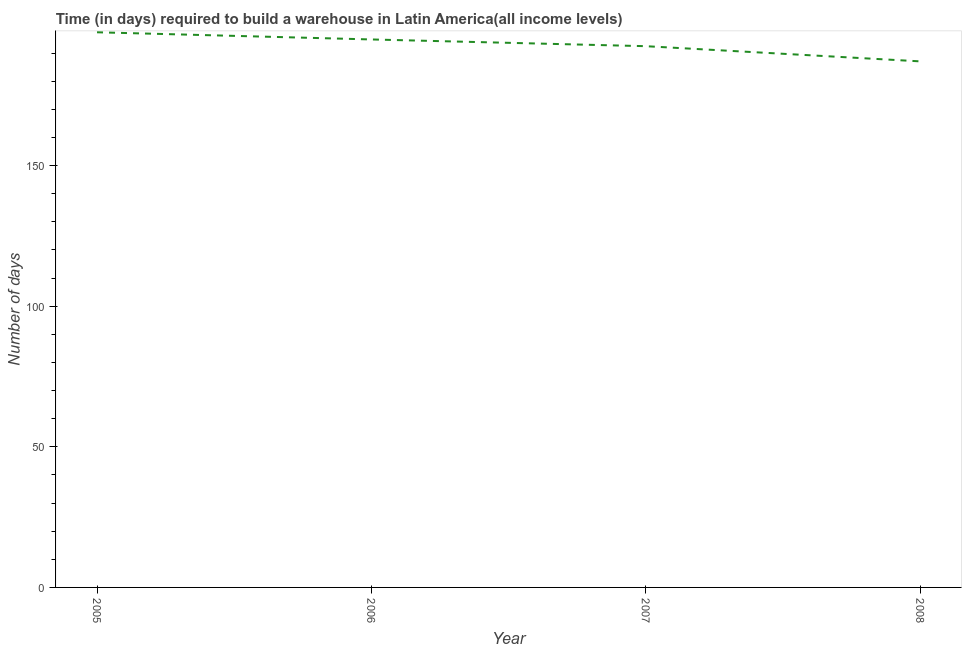What is the time required to build a warehouse in 2008?
Your answer should be compact. 187.07. Across all years, what is the maximum time required to build a warehouse?
Offer a very short reply. 197.41. Across all years, what is the minimum time required to build a warehouse?
Keep it short and to the point. 187.07. In which year was the time required to build a warehouse maximum?
Your answer should be compact. 2005. What is the sum of the time required to build a warehouse?
Ensure brevity in your answer.  771.81. What is the difference between the time required to build a warehouse in 2006 and 2007?
Your response must be concise. 2.4. What is the average time required to build a warehouse per year?
Make the answer very short. 192.95. What is the median time required to build a warehouse?
Give a very brief answer. 193.66. Do a majority of the years between 2006 and 2005 (inclusive) have time required to build a warehouse greater than 180 days?
Provide a succinct answer. No. What is the ratio of the time required to build a warehouse in 2005 to that in 2007?
Provide a succinct answer. 1.03. Is the time required to build a warehouse in 2005 less than that in 2007?
Your answer should be very brief. No. Is the difference between the time required to build a warehouse in 2006 and 2007 greater than the difference between any two years?
Ensure brevity in your answer.  No. What is the difference between the highest and the second highest time required to build a warehouse?
Give a very brief answer. 2.55. Is the sum of the time required to build a warehouse in 2005 and 2006 greater than the maximum time required to build a warehouse across all years?
Your response must be concise. Yes. What is the difference between the highest and the lowest time required to build a warehouse?
Your response must be concise. 10.35. Does the time required to build a warehouse monotonically increase over the years?
Offer a terse response. No. How many years are there in the graph?
Ensure brevity in your answer.  4. What is the difference between two consecutive major ticks on the Y-axis?
Provide a short and direct response. 50. What is the title of the graph?
Provide a short and direct response. Time (in days) required to build a warehouse in Latin America(all income levels). What is the label or title of the X-axis?
Offer a very short reply. Year. What is the label or title of the Y-axis?
Give a very brief answer. Number of days. What is the Number of days in 2005?
Ensure brevity in your answer.  197.41. What is the Number of days of 2006?
Provide a short and direct response. 194.86. What is the Number of days in 2007?
Ensure brevity in your answer.  192.47. What is the Number of days in 2008?
Provide a short and direct response. 187.07. What is the difference between the Number of days in 2005 and 2006?
Ensure brevity in your answer.  2.55. What is the difference between the Number of days in 2005 and 2007?
Give a very brief answer. 4.95. What is the difference between the Number of days in 2005 and 2008?
Your answer should be compact. 10.35. What is the difference between the Number of days in 2006 and 2007?
Make the answer very short. 2.4. What is the difference between the Number of days in 2006 and 2008?
Provide a short and direct response. 7.8. What is the ratio of the Number of days in 2005 to that in 2008?
Offer a terse response. 1.05. What is the ratio of the Number of days in 2006 to that in 2007?
Provide a short and direct response. 1.01. What is the ratio of the Number of days in 2006 to that in 2008?
Provide a short and direct response. 1.04. What is the ratio of the Number of days in 2007 to that in 2008?
Ensure brevity in your answer.  1.03. 